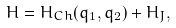Convert formula to latex. <formula><loc_0><loc_0><loc_500><loc_500>H = H _ { C h } ( q _ { 1 } , q _ { 2 } ) + H _ { J } ,</formula> 